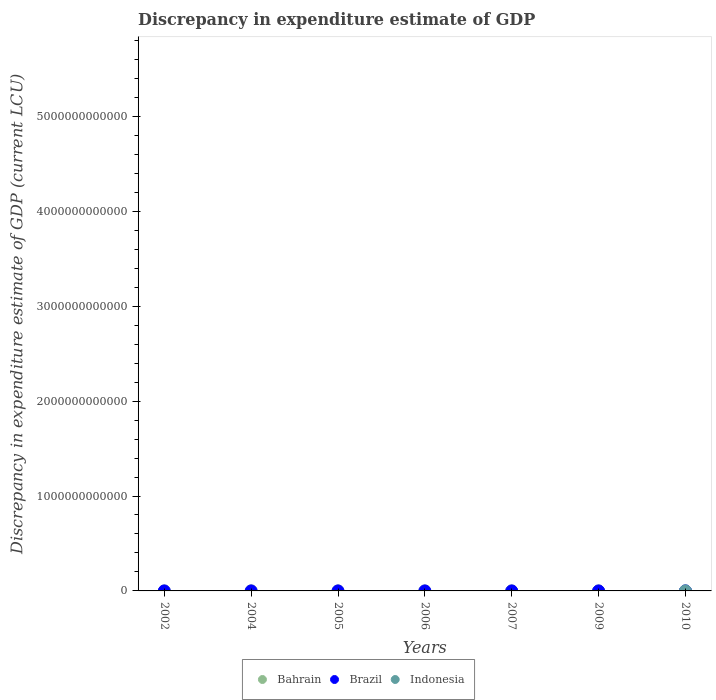Is the number of dotlines equal to the number of legend labels?
Offer a very short reply. No. In which year was the discrepancy in expenditure estimate of GDP in Bahrain maximum?
Give a very brief answer. 2004. What is the total discrepancy in expenditure estimate of GDP in Bahrain in the graph?
Your response must be concise. 6.45e+08. What is the difference between the discrepancy in expenditure estimate of GDP in Bahrain in 2002 and that in 2005?
Offer a very short reply. 1.24e+07. What is the difference between the discrepancy in expenditure estimate of GDP in Brazil in 2002 and the discrepancy in expenditure estimate of GDP in Indonesia in 2007?
Provide a succinct answer. 0. What is the average discrepancy in expenditure estimate of GDP in Bahrain per year?
Offer a very short reply. 9.21e+07. In the year 2005, what is the difference between the discrepancy in expenditure estimate of GDP in Bahrain and discrepancy in expenditure estimate of GDP in Brazil?
Keep it short and to the point. 3.17e+07. What is the difference between the highest and the second highest discrepancy in expenditure estimate of GDP in Brazil?
Make the answer very short. 1.00e+06. What is the difference between the highest and the lowest discrepancy in expenditure estimate of GDP in Bahrain?
Your response must be concise. 5.65e+08. In how many years, is the discrepancy in expenditure estimate of GDP in Bahrain greater than the average discrepancy in expenditure estimate of GDP in Bahrain taken over all years?
Offer a very short reply. 1. Is it the case that in every year, the sum of the discrepancy in expenditure estimate of GDP in Indonesia and discrepancy in expenditure estimate of GDP in Brazil  is greater than the discrepancy in expenditure estimate of GDP in Bahrain?
Provide a short and direct response. No. Does the discrepancy in expenditure estimate of GDP in Bahrain monotonically increase over the years?
Give a very brief answer. No. Is the discrepancy in expenditure estimate of GDP in Bahrain strictly greater than the discrepancy in expenditure estimate of GDP in Indonesia over the years?
Offer a very short reply. Yes. Is the discrepancy in expenditure estimate of GDP in Indonesia strictly less than the discrepancy in expenditure estimate of GDP in Bahrain over the years?
Keep it short and to the point. Yes. What is the difference between two consecutive major ticks on the Y-axis?
Offer a terse response. 1.00e+12. Does the graph contain any zero values?
Your answer should be very brief. Yes. Where does the legend appear in the graph?
Ensure brevity in your answer.  Bottom center. How many legend labels are there?
Offer a very short reply. 3. What is the title of the graph?
Give a very brief answer. Discrepancy in expenditure estimate of GDP. What is the label or title of the Y-axis?
Offer a terse response. Discrepancy in expenditure estimate of GDP (current LCU). What is the Discrepancy in expenditure estimate of GDP (current LCU) in Bahrain in 2002?
Make the answer very short. 4.61e+07. What is the Discrepancy in expenditure estimate of GDP (current LCU) in Indonesia in 2002?
Keep it short and to the point. 0. What is the Discrepancy in expenditure estimate of GDP (current LCU) in Bahrain in 2004?
Provide a succinct answer. 5.65e+08. What is the Discrepancy in expenditure estimate of GDP (current LCU) of Indonesia in 2004?
Your answer should be very brief. 0. What is the Discrepancy in expenditure estimate of GDP (current LCU) of Bahrain in 2005?
Provide a succinct answer. 3.37e+07. What is the Discrepancy in expenditure estimate of GDP (current LCU) of Indonesia in 2005?
Provide a short and direct response. 0. What is the Discrepancy in expenditure estimate of GDP (current LCU) of Bahrain in 2006?
Provide a short and direct response. 0. What is the Discrepancy in expenditure estimate of GDP (current LCU) of Indonesia in 2006?
Offer a very short reply. 0. What is the Discrepancy in expenditure estimate of GDP (current LCU) of Bahrain in 2007?
Keep it short and to the point. 0. What is the Discrepancy in expenditure estimate of GDP (current LCU) in Brazil in 2007?
Offer a terse response. 0. What is the Discrepancy in expenditure estimate of GDP (current LCU) of Indonesia in 2007?
Make the answer very short. 0. What is the Discrepancy in expenditure estimate of GDP (current LCU) in Bahrain in 2009?
Provide a short and direct response. 7.00e+04. What is the Discrepancy in expenditure estimate of GDP (current LCU) of Indonesia in 2009?
Offer a terse response. 0. What is the Discrepancy in expenditure estimate of GDP (current LCU) in Bahrain in 2010?
Give a very brief answer. 0. What is the Discrepancy in expenditure estimate of GDP (current LCU) of Brazil in 2010?
Make the answer very short. 1.00e+06. What is the Discrepancy in expenditure estimate of GDP (current LCU) in Indonesia in 2010?
Your answer should be compact. 0. Across all years, what is the maximum Discrepancy in expenditure estimate of GDP (current LCU) in Bahrain?
Make the answer very short. 5.65e+08. Across all years, what is the minimum Discrepancy in expenditure estimate of GDP (current LCU) in Bahrain?
Your answer should be compact. 0. What is the total Discrepancy in expenditure estimate of GDP (current LCU) of Bahrain in the graph?
Provide a short and direct response. 6.45e+08. What is the total Discrepancy in expenditure estimate of GDP (current LCU) of Brazil in the graph?
Keep it short and to the point. 4.00e+06. What is the difference between the Discrepancy in expenditure estimate of GDP (current LCU) of Bahrain in 2002 and that in 2004?
Keep it short and to the point. -5.19e+08. What is the difference between the Discrepancy in expenditure estimate of GDP (current LCU) of Bahrain in 2002 and that in 2005?
Make the answer very short. 1.24e+07. What is the difference between the Discrepancy in expenditure estimate of GDP (current LCU) of Bahrain in 2002 and that in 2009?
Provide a short and direct response. 4.60e+07. What is the difference between the Discrepancy in expenditure estimate of GDP (current LCU) of Bahrain in 2004 and that in 2005?
Give a very brief answer. 5.31e+08. What is the difference between the Discrepancy in expenditure estimate of GDP (current LCU) in Bahrain in 2004 and that in 2009?
Provide a short and direct response. 5.65e+08. What is the difference between the Discrepancy in expenditure estimate of GDP (current LCU) of Bahrain in 2005 and that in 2009?
Ensure brevity in your answer.  3.36e+07. What is the difference between the Discrepancy in expenditure estimate of GDP (current LCU) in Brazil in 2005 and that in 2010?
Make the answer very short. 1.00e+06. What is the difference between the Discrepancy in expenditure estimate of GDP (current LCU) in Brazil in 2009 and that in 2010?
Ensure brevity in your answer.  -0. What is the difference between the Discrepancy in expenditure estimate of GDP (current LCU) of Bahrain in 2002 and the Discrepancy in expenditure estimate of GDP (current LCU) of Brazil in 2005?
Provide a succinct answer. 4.41e+07. What is the difference between the Discrepancy in expenditure estimate of GDP (current LCU) of Bahrain in 2002 and the Discrepancy in expenditure estimate of GDP (current LCU) of Brazil in 2009?
Offer a terse response. 4.51e+07. What is the difference between the Discrepancy in expenditure estimate of GDP (current LCU) in Bahrain in 2002 and the Discrepancy in expenditure estimate of GDP (current LCU) in Brazil in 2010?
Provide a short and direct response. 4.51e+07. What is the difference between the Discrepancy in expenditure estimate of GDP (current LCU) in Bahrain in 2004 and the Discrepancy in expenditure estimate of GDP (current LCU) in Brazil in 2005?
Provide a succinct answer. 5.63e+08. What is the difference between the Discrepancy in expenditure estimate of GDP (current LCU) in Bahrain in 2004 and the Discrepancy in expenditure estimate of GDP (current LCU) in Brazil in 2009?
Your response must be concise. 5.64e+08. What is the difference between the Discrepancy in expenditure estimate of GDP (current LCU) in Bahrain in 2004 and the Discrepancy in expenditure estimate of GDP (current LCU) in Brazil in 2010?
Offer a terse response. 5.64e+08. What is the difference between the Discrepancy in expenditure estimate of GDP (current LCU) of Bahrain in 2005 and the Discrepancy in expenditure estimate of GDP (current LCU) of Brazil in 2009?
Your response must be concise. 3.27e+07. What is the difference between the Discrepancy in expenditure estimate of GDP (current LCU) of Bahrain in 2005 and the Discrepancy in expenditure estimate of GDP (current LCU) of Brazil in 2010?
Provide a succinct answer. 3.27e+07. What is the difference between the Discrepancy in expenditure estimate of GDP (current LCU) in Bahrain in 2009 and the Discrepancy in expenditure estimate of GDP (current LCU) in Brazil in 2010?
Your response must be concise. -9.30e+05. What is the average Discrepancy in expenditure estimate of GDP (current LCU) in Bahrain per year?
Your answer should be compact. 9.21e+07. What is the average Discrepancy in expenditure estimate of GDP (current LCU) in Brazil per year?
Provide a short and direct response. 5.71e+05. What is the average Discrepancy in expenditure estimate of GDP (current LCU) of Indonesia per year?
Your answer should be compact. 0. In the year 2005, what is the difference between the Discrepancy in expenditure estimate of GDP (current LCU) of Bahrain and Discrepancy in expenditure estimate of GDP (current LCU) of Brazil?
Give a very brief answer. 3.17e+07. In the year 2009, what is the difference between the Discrepancy in expenditure estimate of GDP (current LCU) of Bahrain and Discrepancy in expenditure estimate of GDP (current LCU) of Brazil?
Provide a short and direct response. -9.30e+05. What is the ratio of the Discrepancy in expenditure estimate of GDP (current LCU) of Bahrain in 2002 to that in 2004?
Make the answer very short. 0.08. What is the ratio of the Discrepancy in expenditure estimate of GDP (current LCU) in Bahrain in 2002 to that in 2005?
Your response must be concise. 1.37. What is the ratio of the Discrepancy in expenditure estimate of GDP (current LCU) of Bahrain in 2002 to that in 2009?
Offer a very short reply. 658.83. What is the ratio of the Discrepancy in expenditure estimate of GDP (current LCU) in Bahrain in 2004 to that in 2005?
Keep it short and to the point. 16.78. What is the ratio of the Discrepancy in expenditure estimate of GDP (current LCU) of Bahrain in 2004 to that in 2009?
Your response must be concise. 8071.92. What is the ratio of the Discrepancy in expenditure estimate of GDP (current LCU) of Bahrain in 2005 to that in 2009?
Ensure brevity in your answer.  481.08. What is the ratio of the Discrepancy in expenditure estimate of GDP (current LCU) of Brazil in 2005 to that in 2009?
Provide a succinct answer. 2. What is the difference between the highest and the second highest Discrepancy in expenditure estimate of GDP (current LCU) in Bahrain?
Keep it short and to the point. 5.19e+08. What is the difference between the highest and the second highest Discrepancy in expenditure estimate of GDP (current LCU) of Brazil?
Offer a terse response. 1.00e+06. What is the difference between the highest and the lowest Discrepancy in expenditure estimate of GDP (current LCU) in Bahrain?
Your answer should be very brief. 5.65e+08. 